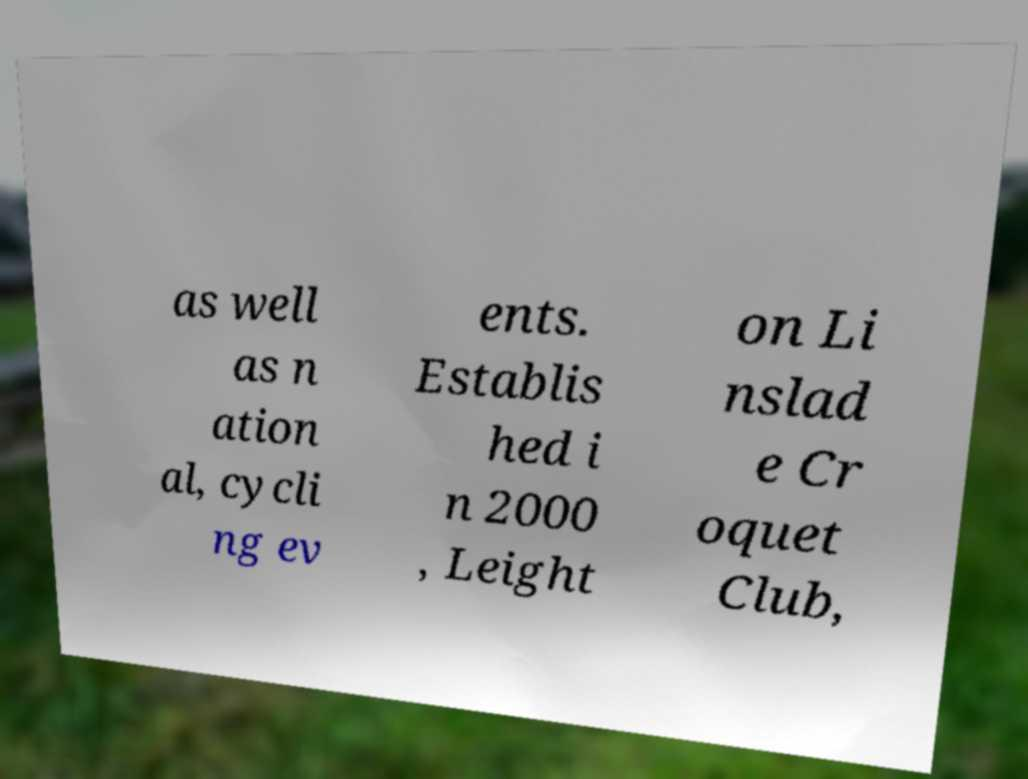I need the written content from this picture converted into text. Can you do that? as well as n ation al, cycli ng ev ents. Establis hed i n 2000 , Leight on Li nslad e Cr oquet Club, 